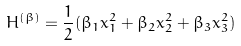<formula> <loc_0><loc_0><loc_500><loc_500>H ^ { ( \beta ) } = \frac { 1 } { 2 } ( \beta _ { 1 } x _ { 1 } ^ { 2 } + \beta _ { 2 } x _ { 2 } ^ { 2 } + \beta _ { 3 } x _ { 3 } ^ { 2 } )</formula> 